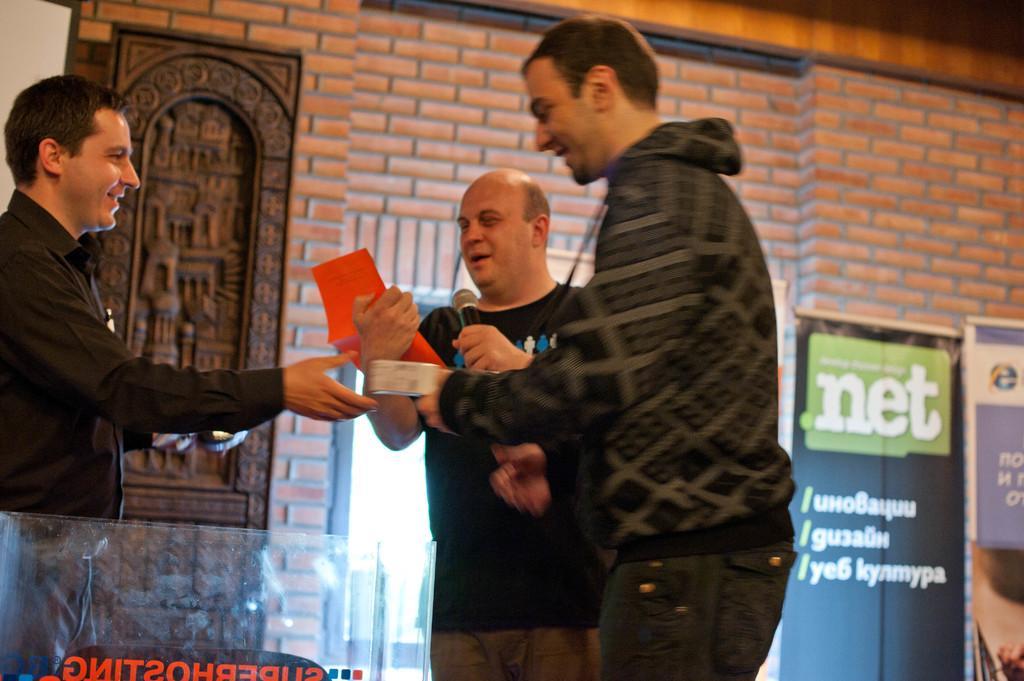In one or two sentences, can you explain what this image depicts? In this picture we can see three men standing and smiling where a man holding a mic and a paper with his hands, banners and in the background we can see the wall. 